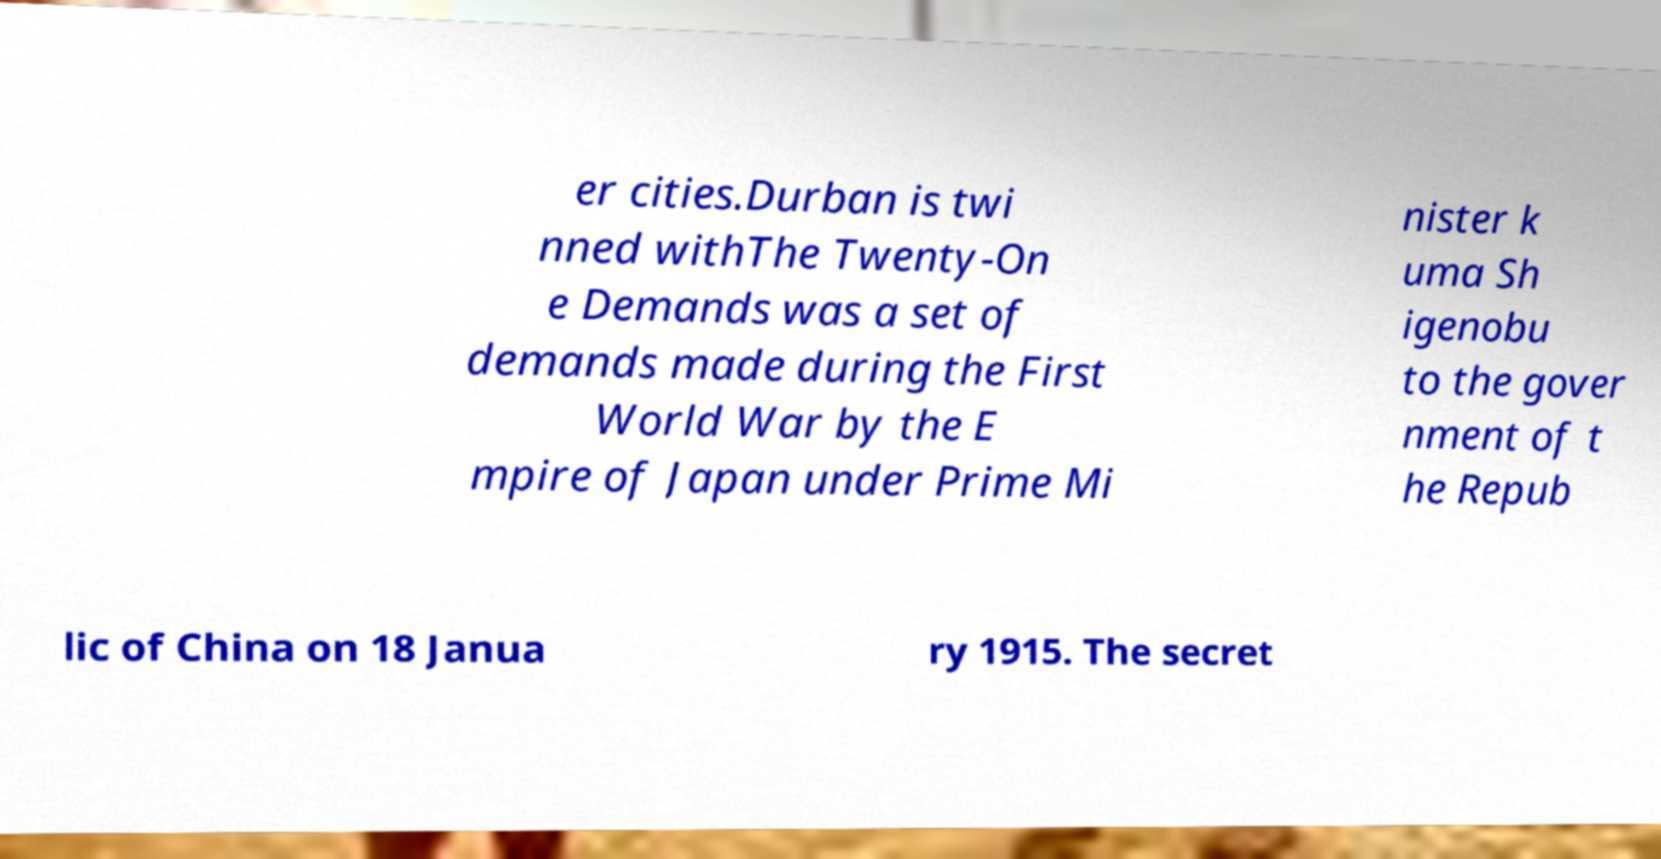Could you assist in decoding the text presented in this image and type it out clearly? er cities.Durban is twi nned withThe Twenty-On e Demands was a set of demands made during the First World War by the E mpire of Japan under Prime Mi nister k uma Sh igenobu to the gover nment of t he Repub lic of China on 18 Janua ry 1915. The secret 